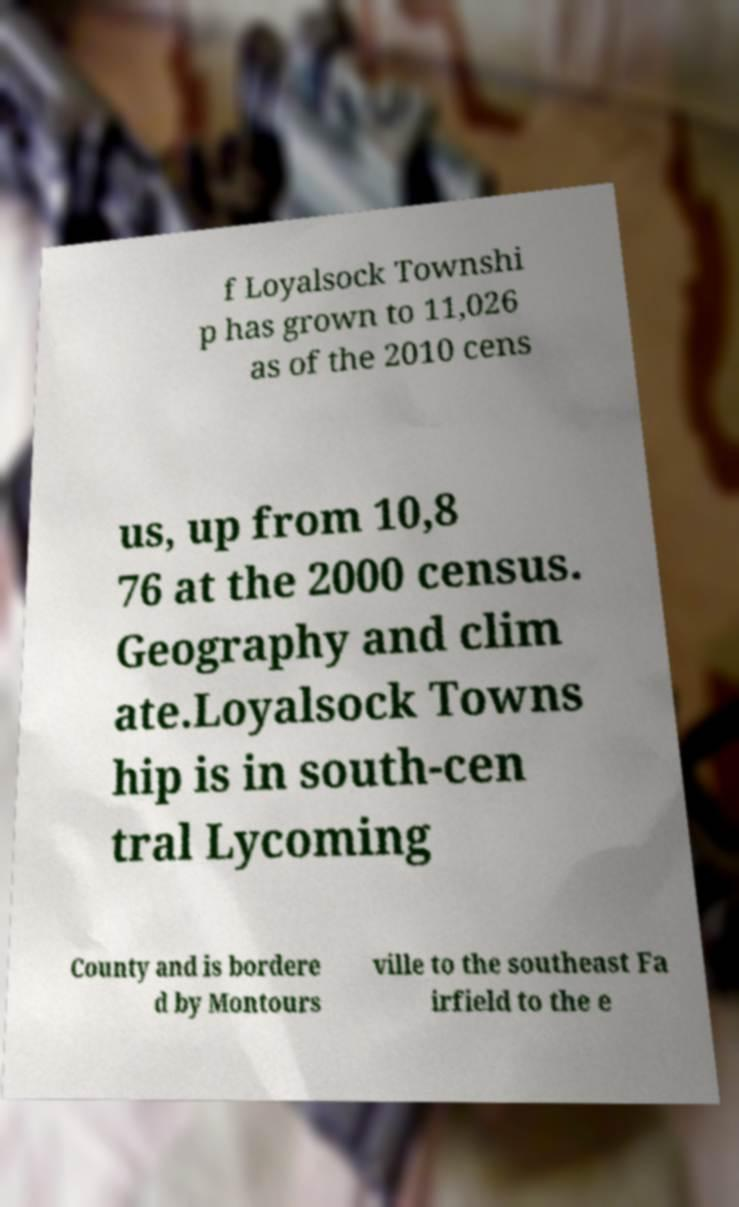Could you extract and type out the text from this image? f Loyalsock Townshi p has grown to 11,026 as of the 2010 cens us, up from 10,8 76 at the 2000 census. Geography and clim ate.Loyalsock Towns hip is in south-cen tral Lycoming County and is bordere d by Montours ville to the southeast Fa irfield to the e 